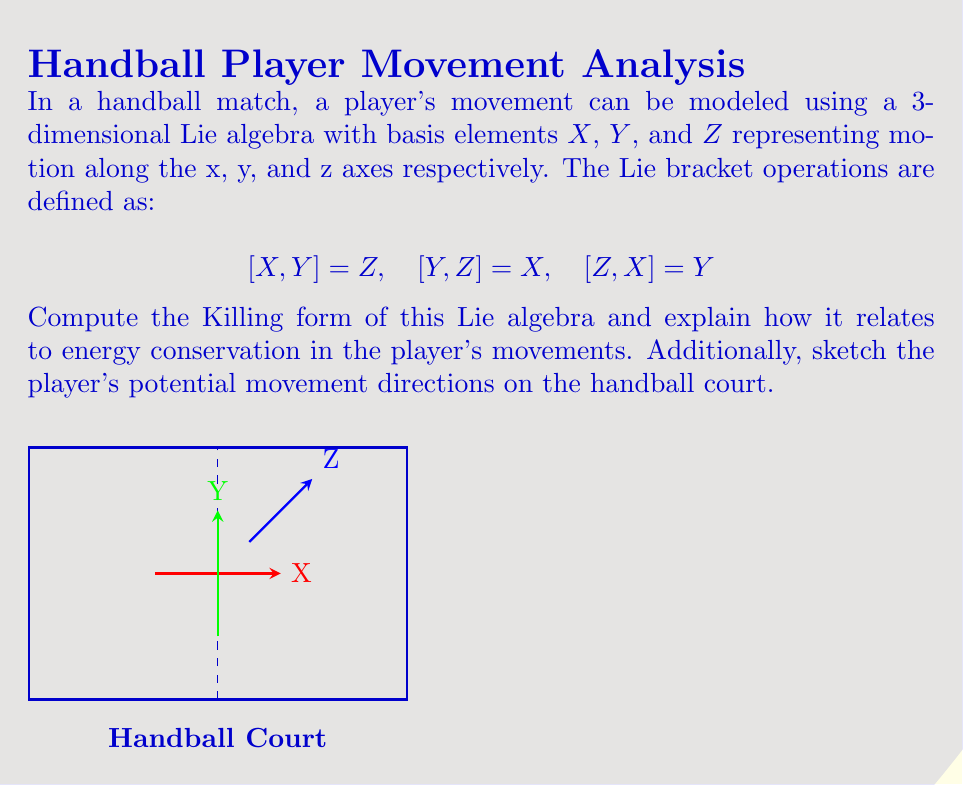Show me your answer to this math problem. Let's approach this step-by-step:

1) The Killing form $B(X,Y)$ of a Lie algebra is defined as:

   $$B(X,Y) = \text{tr}(\text{ad}_X \circ \text{ad}_Y)$$

   where $\text{ad}_X$ is the adjoint representation of $X$.

2) We need to compute the matrices of $\text{ad}_X$, $\text{ad}_Y$, and $\text{ad}_Z$ with respect to the basis $\{X,Y,Z\}$:

   $$\text{ad}_X = \begin{pmatrix} 0 & 0 & -1 \\ 0 & 0 & 1 \\ 0 & -1 & 0 \end{pmatrix}$$
   
   $$\text{ad}_Y = \begin{pmatrix} 0 & 0 & 1 \\ 0 & 0 & 0 \\ -1 & 0 & 0 \end{pmatrix}$$
   
   $$\text{ad}_Z = \begin{pmatrix} 0 & -1 & 0 \\ 1 & 0 & 0 \\ 0 & 0 & 0 \end{pmatrix}$$

3) Now, let's compute $B(X,X)$, $B(Y,Y)$, and $B(Z,Z)$:

   $$B(X,X) = \text{tr}(\text{ad}_X \circ \text{ad}_X) = \text{tr}\begin{pmatrix} -1 & 0 & 0 \\ 0 & -1 & 0 \\ 0 & 0 & -1 \end{pmatrix} = -3$$
   
   Similarly, $B(Y,Y) = B(Z,Z) = -3$

4) For the off-diagonal elements:

   $$B(X,Y) = B(Y,X) = \text{tr}(\text{ad}_X \circ \text{ad}_Y) = \text{tr}\begin{pmatrix} 0 & 1 & 0 \\ -1 & 0 & 0 \\ 0 & 0 & 0 \end{pmatrix} = 0$$
   
   Similarly, $B(Y,Z) = B(Z,Y) = B(X,Z) = B(Z,X) = 0$

5) Therefore, the Killing form matrix is:

   $$B = \begin{pmatrix} -3 & 0 & 0 \\ 0 & -3 & 0 \\ 0 & 0 & -3 \end{pmatrix}$$

6) Relation to energy conservation:
   The Killing form is invariant under the adjoint action of the Lie group, which means it's conserved during the evolution of the system. In the context of handball player movements, this implies that the total energy of the player's motion (kinetic energy in x, y, and z directions) remains constant if we ignore external forces like friction or opponent interactions.

   The negative definite nature of the Killing form (-3 on the diagonal) suggests that the system is stable, which aligns with the idea that a player's movements should be controlled and not diverge to infinity.

7) The sketch shows potential movement directions on the handball court, with X and Y representing horizontal movements and Z representing vertical movements (like jumping).
Answer: $B = \text{diag}(-3,-3,-3)$; conserves total motion energy. 